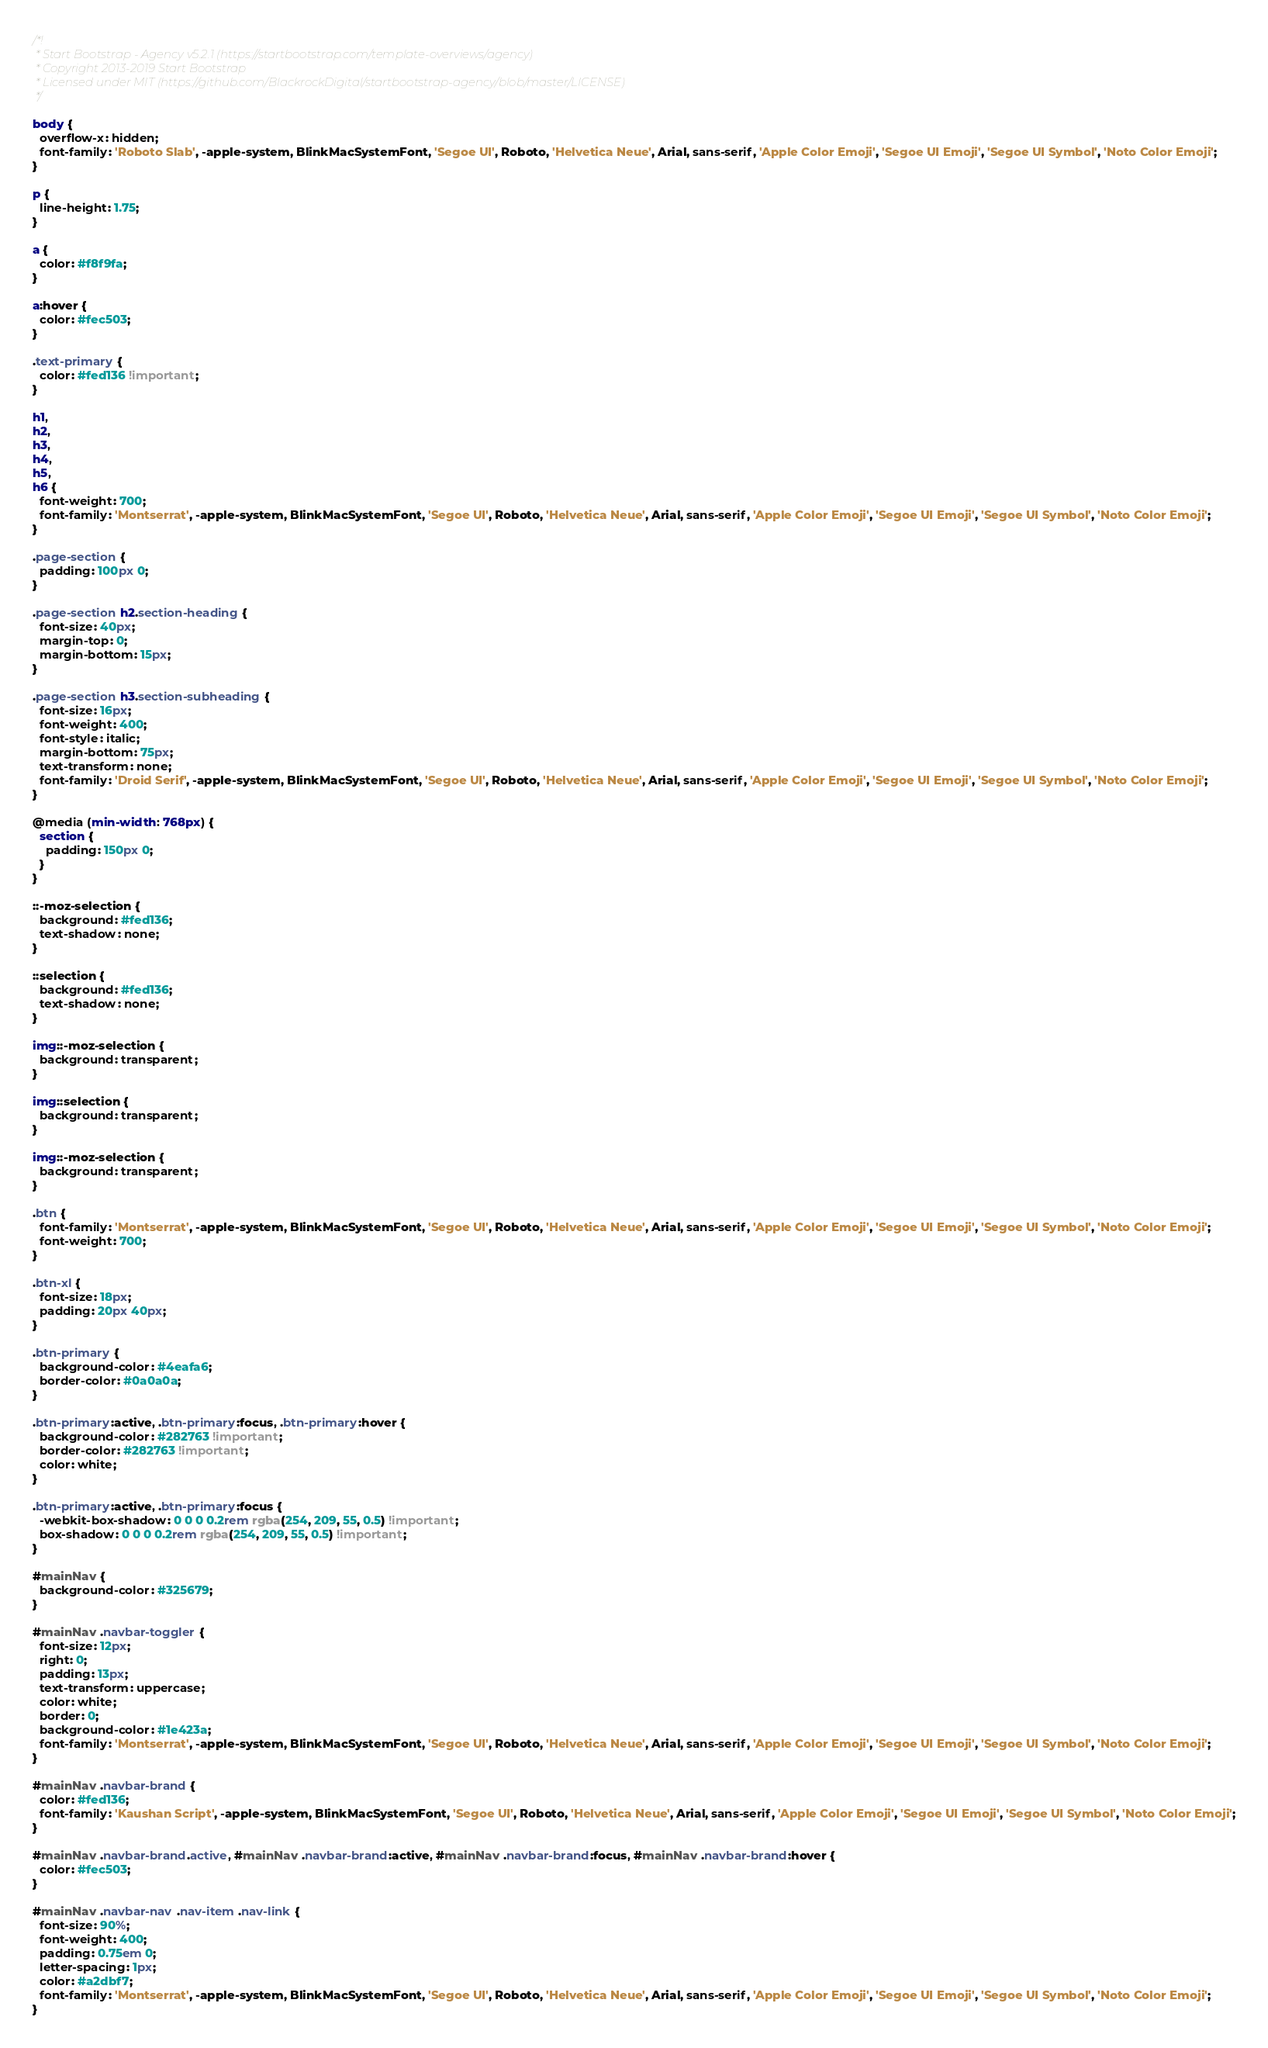Convert code to text. <code><loc_0><loc_0><loc_500><loc_500><_CSS_>/*!
 * Start Bootstrap - Agency v5.2.1 (https://startbootstrap.com/template-overviews/agency)
 * Copyright 2013-2019 Start Bootstrap
 * Licensed under MIT (https://github.com/BlackrockDigital/startbootstrap-agency/blob/master/LICENSE)
 */

body {
  overflow-x: hidden;
  font-family: 'Roboto Slab', -apple-system, BlinkMacSystemFont, 'Segoe UI', Roboto, 'Helvetica Neue', Arial, sans-serif, 'Apple Color Emoji', 'Segoe UI Emoji', 'Segoe UI Symbol', 'Noto Color Emoji';
}

p {
  line-height: 1.75;
}

a {
  color: #f8f9fa;
}

a:hover {
  color: #fec503;
}

.text-primary {
  color: #fed136 !important;
}

h1,
h2,
h3,
h4,
h5,
h6 {
  font-weight: 700;
  font-family: 'Montserrat', -apple-system, BlinkMacSystemFont, 'Segoe UI', Roboto, 'Helvetica Neue', Arial, sans-serif, 'Apple Color Emoji', 'Segoe UI Emoji', 'Segoe UI Symbol', 'Noto Color Emoji';
}

.page-section {
  padding: 100px 0;
}

.page-section h2.section-heading {
  font-size: 40px;
  margin-top: 0;
  margin-bottom: 15px;
}

.page-section h3.section-subheading {
  font-size: 16px;
  font-weight: 400;
  font-style: italic;
  margin-bottom: 75px;
  text-transform: none;
  font-family: 'Droid Serif', -apple-system, BlinkMacSystemFont, 'Segoe UI', Roboto, 'Helvetica Neue', Arial, sans-serif, 'Apple Color Emoji', 'Segoe UI Emoji', 'Segoe UI Symbol', 'Noto Color Emoji';
}

@media (min-width: 768px) {
  section {
    padding: 150px 0;
  }
}

::-moz-selection {
  background: #fed136;
  text-shadow: none;
}

::selection {
  background: #fed136;
  text-shadow: none;
}

img::-moz-selection {
  background: transparent;
}

img::selection {
  background: transparent;
}

img::-moz-selection {
  background: transparent;
}

.btn {
  font-family: 'Montserrat', -apple-system, BlinkMacSystemFont, 'Segoe UI', Roboto, 'Helvetica Neue', Arial, sans-serif, 'Apple Color Emoji', 'Segoe UI Emoji', 'Segoe UI Symbol', 'Noto Color Emoji';
  font-weight: 700;
}

.btn-xl {
  font-size: 18px;
  padding: 20px 40px;
}

.btn-primary {
  background-color: #4eafa6;
  border-color: #0a0a0a;
}

.btn-primary:active, .btn-primary:focus, .btn-primary:hover {
  background-color: #282763 !important;
  border-color: #282763 !important;
  color: white;
}

.btn-primary:active, .btn-primary:focus {
  -webkit-box-shadow: 0 0 0 0.2rem rgba(254, 209, 55, 0.5) !important;
  box-shadow: 0 0 0 0.2rem rgba(254, 209, 55, 0.5) !important;
}

#mainNav {
  background-color: #325679;
}

#mainNav .navbar-toggler {
  font-size: 12px;
  right: 0;
  padding: 13px;
  text-transform: uppercase;
  color: white;
  border: 0;
  background-color: #1e423a;
  font-family: 'Montserrat', -apple-system, BlinkMacSystemFont, 'Segoe UI', Roboto, 'Helvetica Neue', Arial, sans-serif, 'Apple Color Emoji', 'Segoe UI Emoji', 'Segoe UI Symbol', 'Noto Color Emoji';
}

#mainNav .navbar-brand {
  color: #fed136;
  font-family: 'Kaushan Script', -apple-system, BlinkMacSystemFont, 'Segoe UI', Roboto, 'Helvetica Neue', Arial, sans-serif, 'Apple Color Emoji', 'Segoe UI Emoji', 'Segoe UI Symbol', 'Noto Color Emoji';
}

#mainNav .navbar-brand.active, #mainNav .navbar-brand:active, #mainNav .navbar-brand:focus, #mainNav .navbar-brand:hover {
  color: #fec503;
}

#mainNav .navbar-nav .nav-item .nav-link {
  font-size: 90%;
  font-weight: 400;
  padding: 0.75em 0;
  letter-spacing: 1px;
  color: #a2dbf7;
  font-family: 'Montserrat', -apple-system, BlinkMacSystemFont, 'Segoe UI', Roboto, 'Helvetica Neue', Arial, sans-serif, 'Apple Color Emoji', 'Segoe UI Emoji', 'Segoe UI Symbol', 'Noto Color Emoji';
}
</code> 